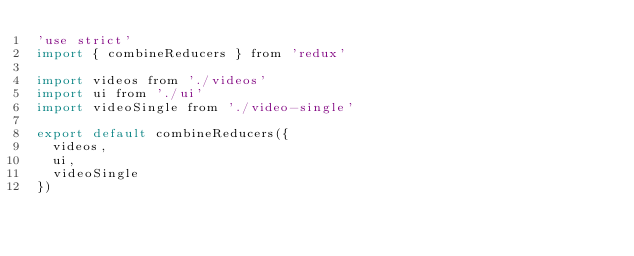Convert code to text. <code><loc_0><loc_0><loc_500><loc_500><_JavaScript_>'use strict'
import { combineReducers } from 'redux'

import videos from './videos'
import ui from './ui'
import videoSingle from './video-single'

export default combineReducers({
  videos,
  ui,
  videoSingle
})
</code> 